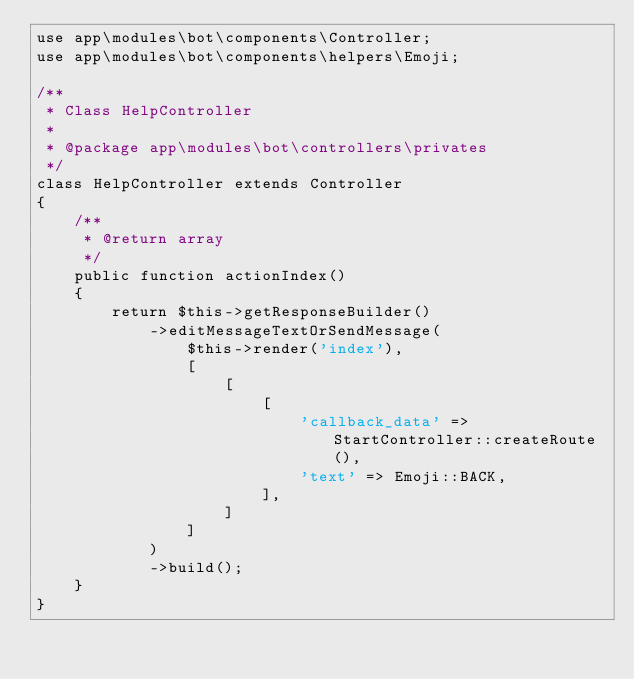Convert code to text. <code><loc_0><loc_0><loc_500><loc_500><_PHP_>use app\modules\bot\components\Controller;
use app\modules\bot\components\helpers\Emoji;

/**
 * Class HelpController
 *
 * @package app\modules\bot\controllers\privates
 */
class HelpController extends Controller
{
    /**
     * @return array
     */
    public function actionIndex()
    {
        return $this->getResponseBuilder()
            ->editMessageTextOrSendMessage(
                $this->render('index'),
                [
                    [
                        [
                            'callback_data' => StartController::createRoute(),
                            'text' => Emoji::BACK,
                        ],
                    ]
                ]
            )
            ->build();
    }
}
</code> 